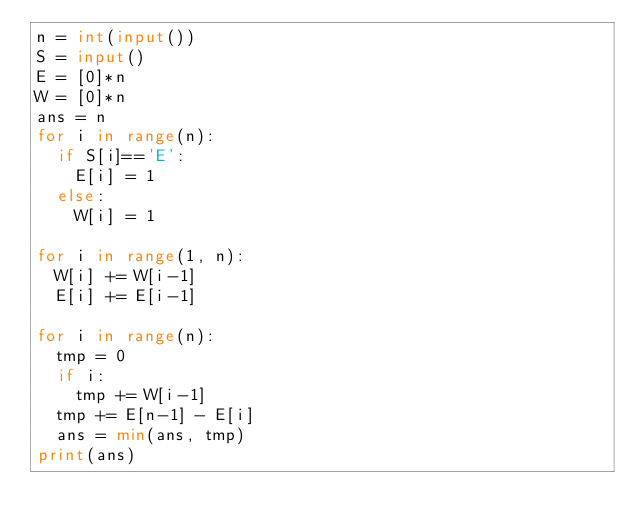Convert code to text. <code><loc_0><loc_0><loc_500><loc_500><_Python_>n = int(input())
S = input()
E = [0]*n
W = [0]*n
ans = n
for i in range(n):
  if S[i]=='E':
    E[i] = 1
  else:
    W[i] = 1

for i in range(1, n):
  W[i] += W[i-1]
  E[i] += E[i-1]

for i in range(n):
  tmp = 0
  if i:
    tmp += W[i-1]
  tmp += E[n-1] - E[i]
  ans = min(ans, tmp)
print(ans)</code> 